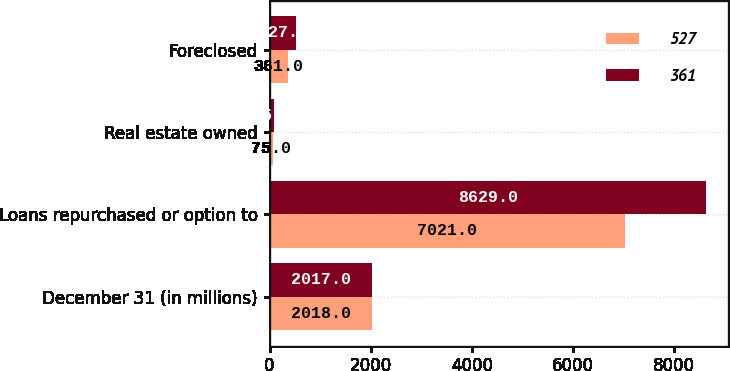<chart> <loc_0><loc_0><loc_500><loc_500><stacked_bar_chart><ecel><fcel>December 31 (in millions)<fcel>Loans repurchased or option to<fcel>Real estate owned<fcel>Foreclosed<nl><fcel>527<fcel>2018<fcel>7021<fcel>75<fcel>361<nl><fcel>361<fcel>2017<fcel>8629<fcel>95<fcel>527<nl></chart> 